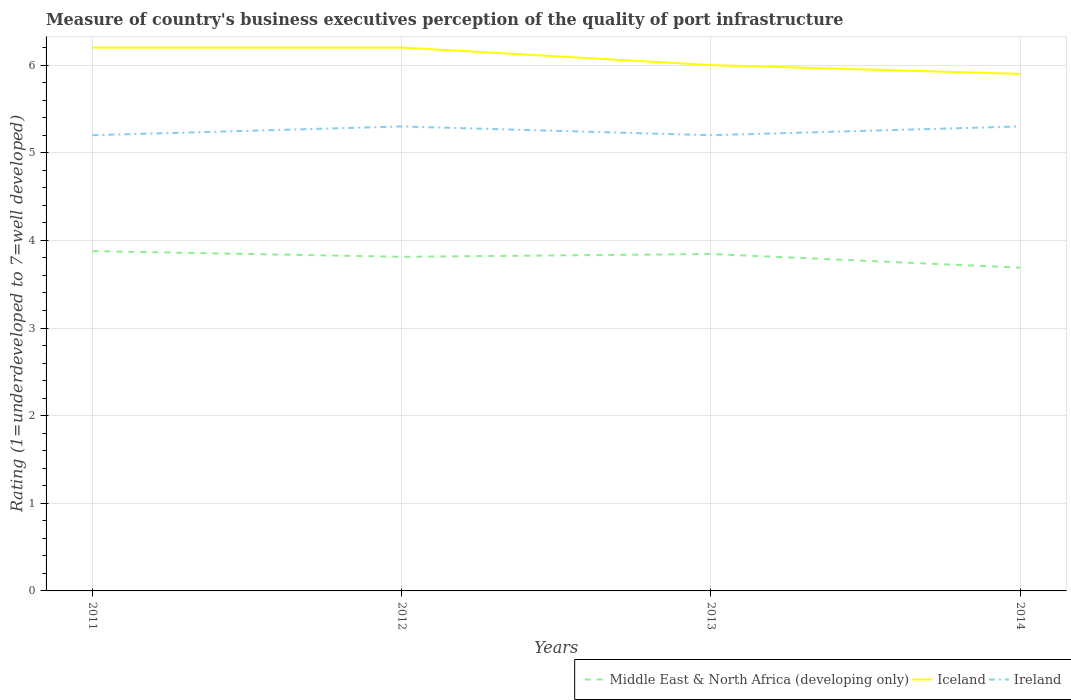How many different coloured lines are there?
Provide a short and direct response. 3. In which year was the ratings of the quality of port infrastructure in Ireland maximum?
Provide a short and direct response. 2011. What is the total ratings of the quality of port infrastructure in Middle East & North Africa (developing only) in the graph?
Your response must be concise. 0.07. What is the difference between the highest and the second highest ratings of the quality of port infrastructure in Middle East & North Africa (developing only)?
Give a very brief answer. 0.19. What is the difference between the highest and the lowest ratings of the quality of port infrastructure in Ireland?
Provide a short and direct response. 2. Is the ratings of the quality of port infrastructure in Middle East & North Africa (developing only) strictly greater than the ratings of the quality of port infrastructure in Ireland over the years?
Provide a succinct answer. Yes. How many lines are there?
Give a very brief answer. 3. Does the graph contain any zero values?
Ensure brevity in your answer.  No. How many legend labels are there?
Offer a very short reply. 3. How are the legend labels stacked?
Ensure brevity in your answer.  Horizontal. What is the title of the graph?
Provide a succinct answer. Measure of country's business executives perception of the quality of port infrastructure. Does "Nigeria" appear as one of the legend labels in the graph?
Your answer should be very brief. No. What is the label or title of the X-axis?
Your response must be concise. Years. What is the label or title of the Y-axis?
Offer a terse response. Rating (1=underdeveloped to 7=well developed). What is the Rating (1=underdeveloped to 7=well developed) of Middle East & North Africa (developing only) in 2011?
Provide a short and direct response. 3.88. What is the Rating (1=underdeveloped to 7=well developed) in Ireland in 2011?
Ensure brevity in your answer.  5.2. What is the Rating (1=underdeveloped to 7=well developed) in Middle East & North Africa (developing only) in 2012?
Keep it short and to the point. 3.81. What is the Rating (1=underdeveloped to 7=well developed) in Ireland in 2012?
Your answer should be very brief. 5.3. What is the Rating (1=underdeveloped to 7=well developed) of Middle East & North Africa (developing only) in 2013?
Provide a succinct answer. 3.84. What is the Rating (1=underdeveloped to 7=well developed) of Middle East & North Africa (developing only) in 2014?
Keep it short and to the point. 3.69. Across all years, what is the maximum Rating (1=underdeveloped to 7=well developed) in Middle East & North Africa (developing only)?
Your answer should be very brief. 3.88. Across all years, what is the maximum Rating (1=underdeveloped to 7=well developed) of Ireland?
Your answer should be compact. 5.3. Across all years, what is the minimum Rating (1=underdeveloped to 7=well developed) of Middle East & North Africa (developing only)?
Provide a short and direct response. 3.69. Across all years, what is the minimum Rating (1=underdeveloped to 7=well developed) in Iceland?
Keep it short and to the point. 5.9. What is the total Rating (1=underdeveloped to 7=well developed) in Middle East & North Africa (developing only) in the graph?
Provide a short and direct response. 15.22. What is the total Rating (1=underdeveloped to 7=well developed) of Iceland in the graph?
Offer a very short reply. 24.3. What is the difference between the Rating (1=underdeveloped to 7=well developed) of Middle East & North Africa (developing only) in 2011 and that in 2012?
Give a very brief answer. 0.07. What is the difference between the Rating (1=underdeveloped to 7=well developed) in Iceland in 2011 and that in 2013?
Offer a terse response. 0.2. What is the difference between the Rating (1=underdeveloped to 7=well developed) of Ireland in 2011 and that in 2013?
Provide a short and direct response. 0. What is the difference between the Rating (1=underdeveloped to 7=well developed) of Middle East & North Africa (developing only) in 2011 and that in 2014?
Make the answer very short. 0.19. What is the difference between the Rating (1=underdeveloped to 7=well developed) in Iceland in 2011 and that in 2014?
Your response must be concise. 0.3. What is the difference between the Rating (1=underdeveloped to 7=well developed) of Middle East & North Africa (developing only) in 2012 and that in 2013?
Your answer should be very brief. -0.03. What is the difference between the Rating (1=underdeveloped to 7=well developed) of Iceland in 2012 and that in 2013?
Offer a terse response. 0.2. What is the difference between the Rating (1=underdeveloped to 7=well developed) of Ireland in 2012 and that in 2013?
Your answer should be very brief. 0.1. What is the difference between the Rating (1=underdeveloped to 7=well developed) of Middle East & North Africa (developing only) in 2012 and that in 2014?
Offer a terse response. 0.12. What is the difference between the Rating (1=underdeveloped to 7=well developed) in Ireland in 2012 and that in 2014?
Make the answer very short. 0. What is the difference between the Rating (1=underdeveloped to 7=well developed) of Middle East & North Africa (developing only) in 2013 and that in 2014?
Keep it short and to the point. 0.16. What is the difference between the Rating (1=underdeveloped to 7=well developed) of Iceland in 2013 and that in 2014?
Offer a terse response. 0.1. What is the difference between the Rating (1=underdeveloped to 7=well developed) in Middle East & North Africa (developing only) in 2011 and the Rating (1=underdeveloped to 7=well developed) in Iceland in 2012?
Your response must be concise. -2.32. What is the difference between the Rating (1=underdeveloped to 7=well developed) in Middle East & North Africa (developing only) in 2011 and the Rating (1=underdeveloped to 7=well developed) in Ireland in 2012?
Your response must be concise. -1.42. What is the difference between the Rating (1=underdeveloped to 7=well developed) in Iceland in 2011 and the Rating (1=underdeveloped to 7=well developed) in Ireland in 2012?
Your response must be concise. 0.9. What is the difference between the Rating (1=underdeveloped to 7=well developed) of Middle East & North Africa (developing only) in 2011 and the Rating (1=underdeveloped to 7=well developed) of Iceland in 2013?
Ensure brevity in your answer.  -2.12. What is the difference between the Rating (1=underdeveloped to 7=well developed) in Middle East & North Africa (developing only) in 2011 and the Rating (1=underdeveloped to 7=well developed) in Ireland in 2013?
Make the answer very short. -1.32. What is the difference between the Rating (1=underdeveloped to 7=well developed) of Middle East & North Africa (developing only) in 2011 and the Rating (1=underdeveloped to 7=well developed) of Iceland in 2014?
Your answer should be compact. -2.02. What is the difference between the Rating (1=underdeveloped to 7=well developed) of Middle East & North Africa (developing only) in 2011 and the Rating (1=underdeveloped to 7=well developed) of Ireland in 2014?
Make the answer very short. -1.42. What is the difference between the Rating (1=underdeveloped to 7=well developed) of Middle East & North Africa (developing only) in 2012 and the Rating (1=underdeveloped to 7=well developed) of Iceland in 2013?
Give a very brief answer. -2.19. What is the difference between the Rating (1=underdeveloped to 7=well developed) of Middle East & North Africa (developing only) in 2012 and the Rating (1=underdeveloped to 7=well developed) of Ireland in 2013?
Make the answer very short. -1.39. What is the difference between the Rating (1=underdeveloped to 7=well developed) in Iceland in 2012 and the Rating (1=underdeveloped to 7=well developed) in Ireland in 2013?
Give a very brief answer. 1. What is the difference between the Rating (1=underdeveloped to 7=well developed) of Middle East & North Africa (developing only) in 2012 and the Rating (1=underdeveloped to 7=well developed) of Iceland in 2014?
Ensure brevity in your answer.  -2.09. What is the difference between the Rating (1=underdeveloped to 7=well developed) of Middle East & North Africa (developing only) in 2012 and the Rating (1=underdeveloped to 7=well developed) of Ireland in 2014?
Make the answer very short. -1.49. What is the difference between the Rating (1=underdeveloped to 7=well developed) of Middle East & North Africa (developing only) in 2013 and the Rating (1=underdeveloped to 7=well developed) of Iceland in 2014?
Your answer should be compact. -2.06. What is the difference between the Rating (1=underdeveloped to 7=well developed) in Middle East & North Africa (developing only) in 2013 and the Rating (1=underdeveloped to 7=well developed) in Ireland in 2014?
Provide a short and direct response. -1.46. What is the difference between the Rating (1=underdeveloped to 7=well developed) of Iceland in 2013 and the Rating (1=underdeveloped to 7=well developed) of Ireland in 2014?
Make the answer very short. 0.7. What is the average Rating (1=underdeveloped to 7=well developed) in Middle East & North Africa (developing only) per year?
Offer a terse response. 3.81. What is the average Rating (1=underdeveloped to 7=well developed) in Iceland per year?
Offer a very short reply. 6.08. What is the average Rating (1=underdeveloped to 7=well developed) of Ireland per year?
Give a very brief answer. 5.25. In the year 2011, what is the difference between the Rating (1=underdeveloped to 7=well developed) in Middle East & North Africa (developing only) and Rating (1=underdeveloped to 7=well developed) in Iceland?
Offer a very short reply. -2.32. In the year 2011, what is the difference between the Rating (1=underdeveloped to 7=well developed) of Middle East & North Africa (developing only) and Rating (1=underdeveloped to 7=well developed) of Ireland?
Your answer should be compact. -1.32. In the year 2012, what is the difference between the Rating (1=underdeveloped to 7=well developed) of Middle East & North Africa (developing only) and Rating (1=underdeveloped to 7=well developed) of Iceland?
Provide a short and direct response. -2.39. In the year 2012, what is the difference between the Rating (1=underdeveloped to 7=well developed) of Middle East & North Africa (developing only) and Rating (1=underdeveloped to 7=well developed) of Ireland?
Provide a short and direct response. -1.49. In the year 2013, what is the difference between the Rating (1=underdeveloped to 7=well developed) in Middle East & North Africa (developing only) and Rating (1=underdeveloped to 7=well developed) in Iceland?
Ensure brevity in your answer.  -2.16. In the year 2013, what is the difference between the Rating (1=underdeveloped to 7=well developed) in Middle East & North Africa (developing only) and Rating (1=underdeveloped to 7=well developed) in Ireland?
Give a very brief answer. -1.36. In the year 2013, what is the difference between the Rating (1=underdeveloped to 7=well developed) of Iceland and Rating (1=underdeveloped to 7=well developed) of Ireland?
Give a very brief answer. 0.8. In the year 2014, what is the difference between the Rating (1=underdeveloped to 7=well developed) in Middle East & North Africa (developing only) and Rating (1=underdeveloped to 7=well developed) in Iceland?
Keep it short and to the point. -2.21. In the year 2014, what is the difference between the Rating (1=underdeveloped to 7=well developed) in Middle East & North Africa (developing only) and Rating (1=underdeveloped to 7=well developed) in Ireland?
Provide a succinct answer. -1.61. What is the ratio of the Rating (1=underdeveloped to 7=well developed) of Middle East & North Africa (developing only) in 2011 to that in 2012?
Ensure brevity in your answer.  1.02. What is the ratio of the Rating (1=underdeveloped to 7=well developed) in Ireland in 2011 to that in 2012?
Provide a succinct answer. 0.98. What is the ratio of the Rating (1=underdeveloped to 7=well developed) of Middle East & North Africa (developing only) in 2011 to that in 2013?
Make the answer very short. 1.01. What is the ratio of the Rating (1=underdeveloped to 7=well developed) in Ireland in 2011 to that in 2013?
Offer a terse response. 1. What is the ratio of the Rating (1=underdeveloped to 7=well developed) of Middle East & North Africa (developing only) in 2011 to that in 2014?
Give a very brief answer. 1.05. What is the ratio of the Rating (1=underdeveloped to 7=well developed) of Iceland in 2011 to that in 2014?
Provide a short and direct response. 1.05. What is the ratio of the Rating (1=underdeveloped to 7=well developed) of Ireland in 2011 to that in 2014?
Offer a very short reply. 0.98. What is the ratio of the Rating (1=underdeveloped to 7=well developed) in Middle East & North Africa (developing only) in 2012 to that in 2013?
Make the answer very short. 0.99. What is the ratio of the Rating (1=underdeveloped to 7=well developed) of Iceland in 2012 to that in 2013?
Provide a short and direct response. 1.03. What is the ratio of the Rating (1=underdeveloped to 7=well developed) of Ireland in 2012 to that in 2013?
Make the answer very short. 1.02. What is the ratio of the Rating (1=underdeveloped to 7=well developed) of Middle East & North Africa (developing only) in 2012 to that in 2014?
Make the answer very short. 1.03. What is the ratio of the Rating (1=underdeveloped to 7=well developed) in Iceland in 2012 to that in 2014?
Your answer should be compact. 1.05. What is the ratio of the Rating (1=underdeveloped to 7=well developed) of Middle East & North Africa (developing only) in 2013 to that in 2014?
Provide a succinct answer. 1.04. What is the ratio of the Rating (1=underdeveloped to 7=well developed) of Iceland in 2013 to that in 2014?
Your response must be concise. 1.02. What is the ratio of the Rating (1=underdeveloped to 7=well developed) in Ireland in 2013 to that in 2014?
Provide a succinct answer. 0.98. What is the difference between the highest and the lowest Rating (1=underdeveloped to 7=well developed) of Middle East & North Africa (developing only)?
Your answer should be compact. 0.19. What is the difference between the highest and the lowest Rating (1=underdeveloped to 7=well developed) in Iceland?
Your answer should be very brief. 0.3. What is the difference between the highest and the lowest Rating (1=underdeveloped to 7=well developed) of Ireland?
Offer a very short reply. 0.1. 